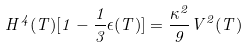<formula> <loc_0><loc_0><loc_500><loc_500>H ^ { 4 } ( T ) [ 1 - \frac { 1 } { 3 } \epsilon ( T ) ] = \frac { \kappa ^ { 2 } } { 9 } V ^ { 2 } ( T )</formula> 